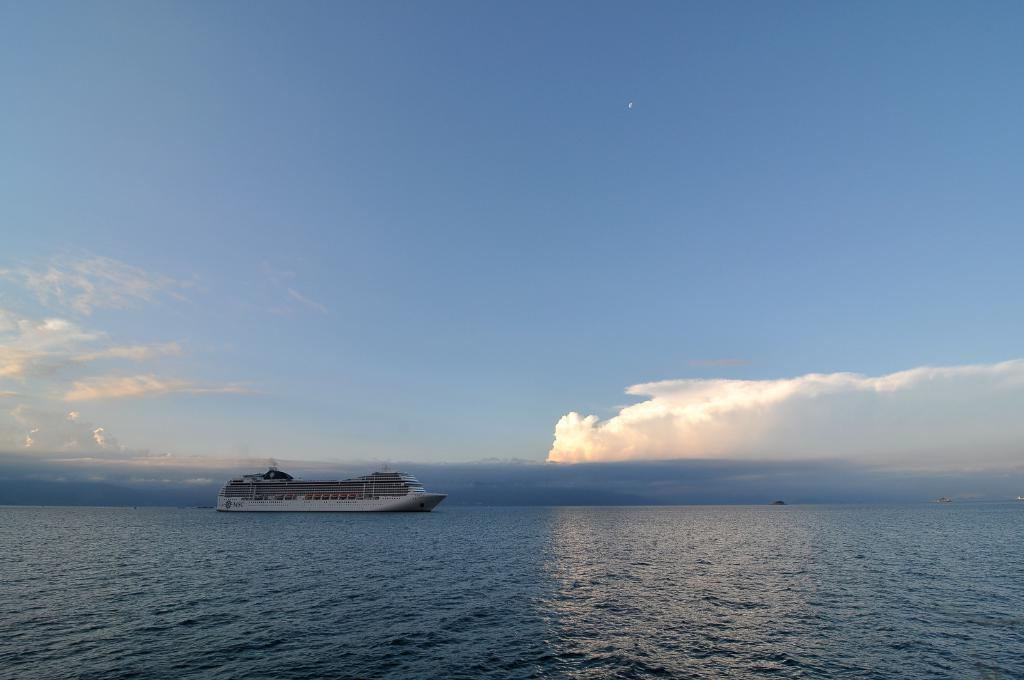What is the main subject of the image? The main subject of the image is a ship. Where is the ship located in the image? The ship is on the water in the image. What else can be seen in the image besides the ship? There is a sky visible in the image. What type of canvas is used to create the ship in the image? The image does not depict a painting or any canvas; it shows a real ship on the water. 